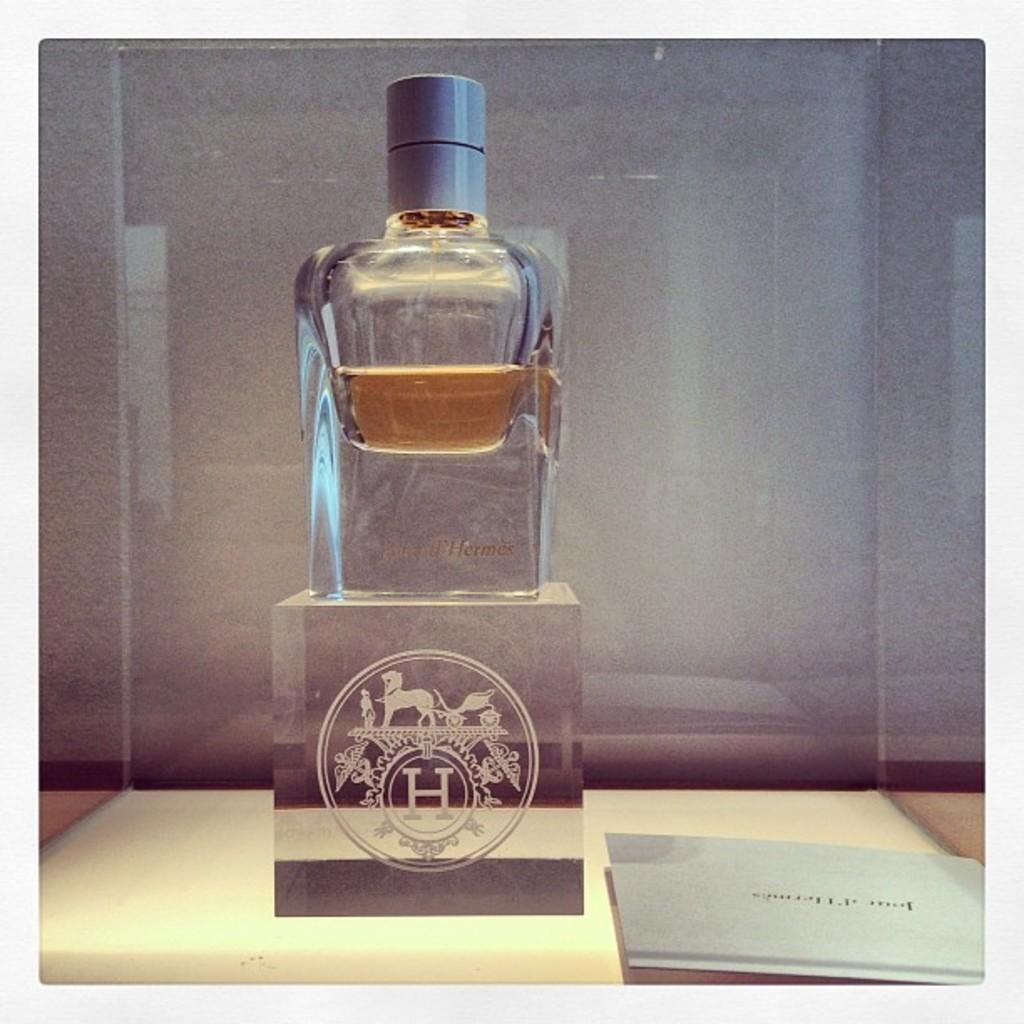Provide a one-sentence caption for the provided image. A bottle with amber colored liquid in it with a stylized H under it. 